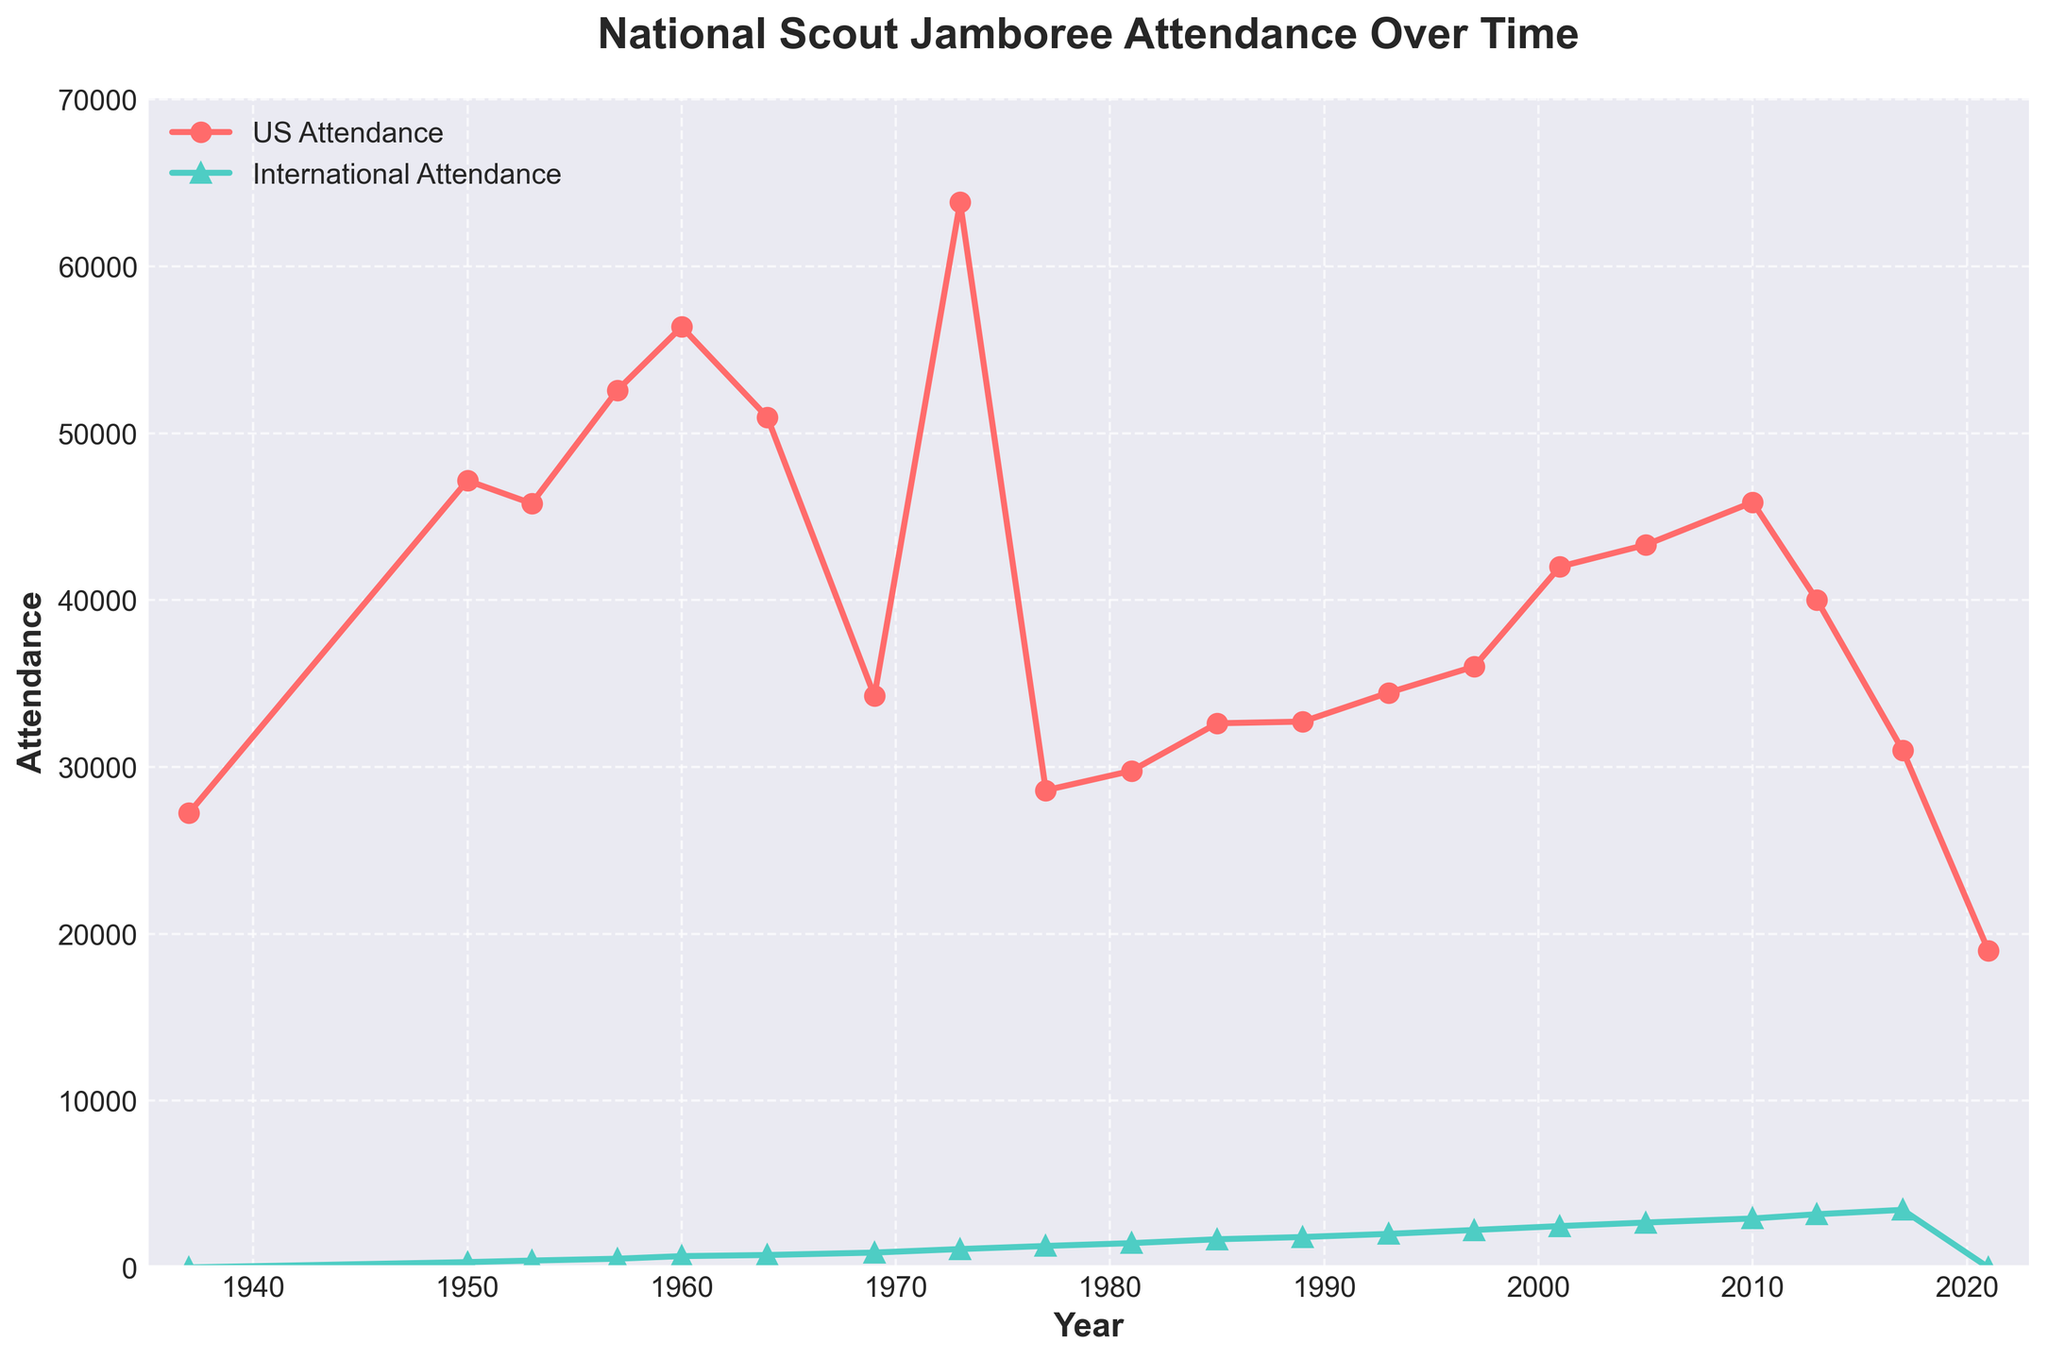Which year had the highest US attendance? By looking at the line representing US attendance, the highest point on the plot is at the year 1973.
Answer: 1973 What is the difference in international attendance between 1960 and 1981? Find the points for the years 1960 and 1981 on the international attendance line. The attendance in 1960 is 678 and in 1981 is 1456. The difference is 1456 - 678.
Answer: 778 Which year shows a significant drop in US attendance after a previous high? Observe the trend of US attendance; there is a significant drop after the year 2010, from 45867 to 40000 in 2013.
Answer: 2013 What is the average international attendance between 2001 and 2010? Look at the international attendance values for the years 2001, 2005, and 2010, which are 2478, 2691, and 2934 respectively. Sum these values and divide by three: (2478 + 2691 + 2934) / 3.
Answer: 2701 Which line, US attendance or International attendance, shows a more consistent increase over time? Observe the overall trend of both lines. The international attendance line consistently rises, while the US attendance line fluctuates more.
Answer: International attendance What was the US attendance in 1937 and how does it compare to the international attendance in the same year? Find the points for the year 1937. The US attendance is 27232, and the international attendance is 0.
Answer: 27232 and 0 How does the US attendance in 2021 compare to that in 2017? Look at the points for the years 2017 and 2021. In 2017, the US attendance is 31000, while in 2021, it is 19000.
Answer: 31000 is higher In which years did international attendance exceed 2000? Observe the points on the international attendance line above 2000. These years are 1993 and beyond.
Answer: 1993 onward What is the total attendance combining US and international participants in 1973? Add the US and international attendance for the year 1973: 63842 (US) + 1102 (International).
Answer: 64944 